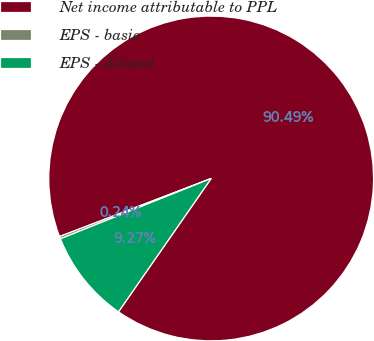Convert chart to OTSL. <chart><loc_0><loc_0><loc_500><loc_500><pie_chart><fcel>Net income attributable to PPL<fcel>EPS - basic<fcel>EPS - diluted<nl><fcel>90.49%<fcel>0.24%<fcel>9.27%<nl></chart> 